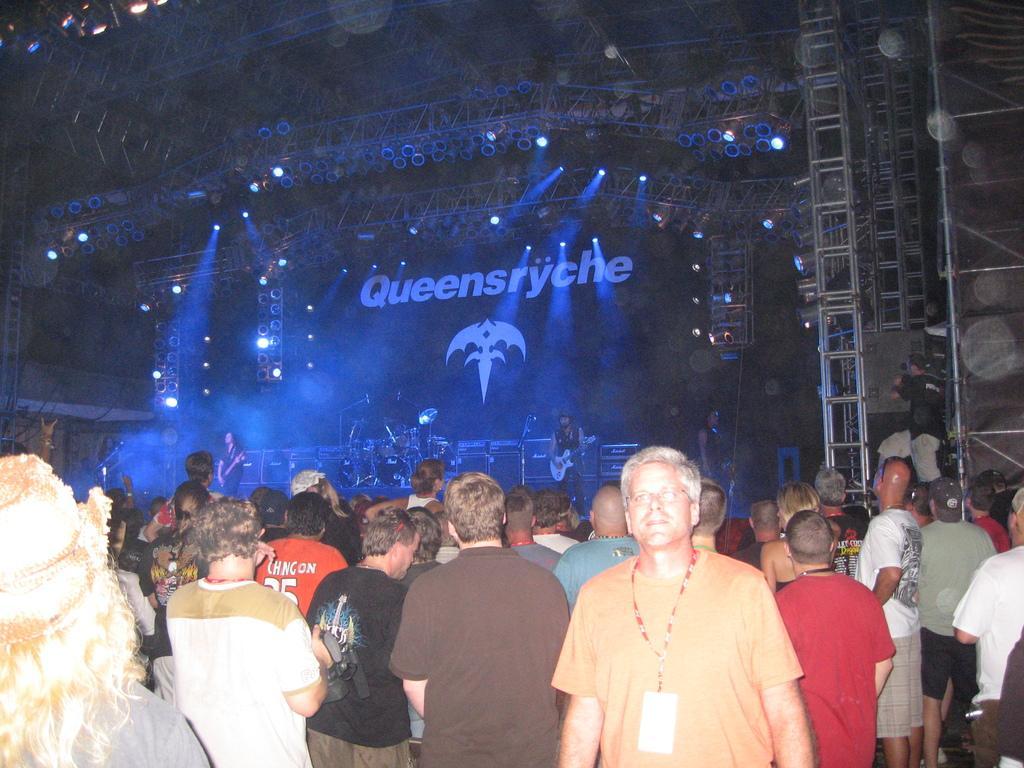Can you describe this image briefly? In this image there are people standing, in the background there are people playing musical instruments and there is a banner, on that banner there is some text, at the top there are lights and iron roads. 